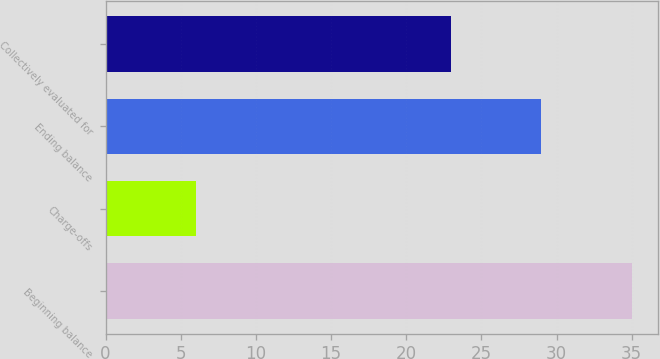Convert chart to OTSL. <chart><loc_0><loc_0><loc_500><loc_500><bar_chart><fcel>Beginning balance<fcel>Charge-offs<fcel>Ending balance<fcel>Collectively evaluated for<nl><fcel>35<fcel>6<fcel>29<fcel>23<nl></chart> 